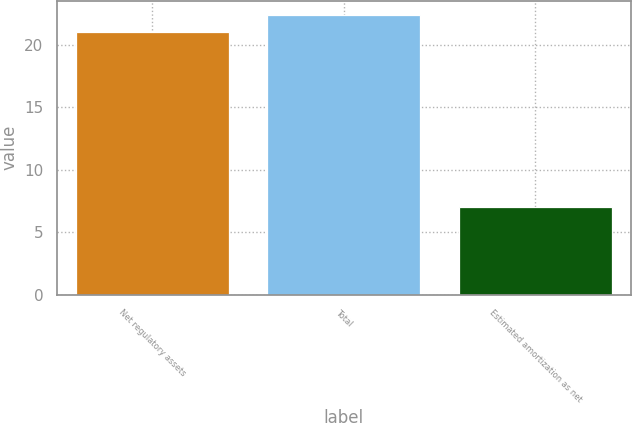Convert chart. <chart><loc_0><loc_0><loc_500><loc_500><bar_chart><fcel>Net regulatory assets<fcel>Total<fcel>Estimated amortization as net<nl><fcel>21<fcel>22.4<fcel>7<nl></chart> 